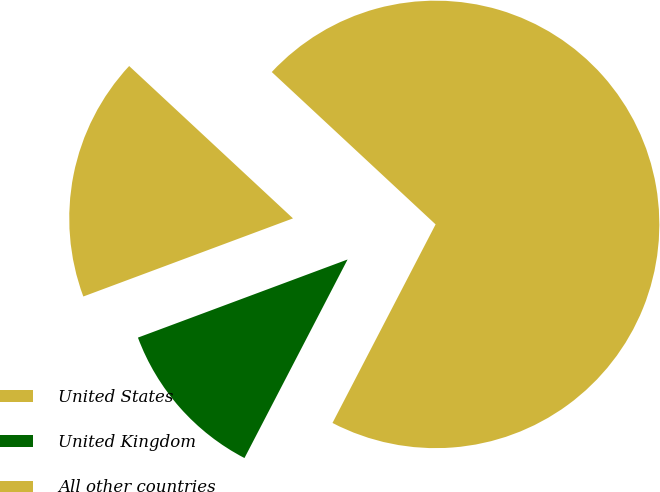<chart> <loc_0><loc_0><loc_500><loc_500><pie_chart><fcel>United States<fcel>United Kingdom<fcel>All other countries<nl><fcel>70.7%<fcel>11.7%<fcel>17.6%<nl></chart> 